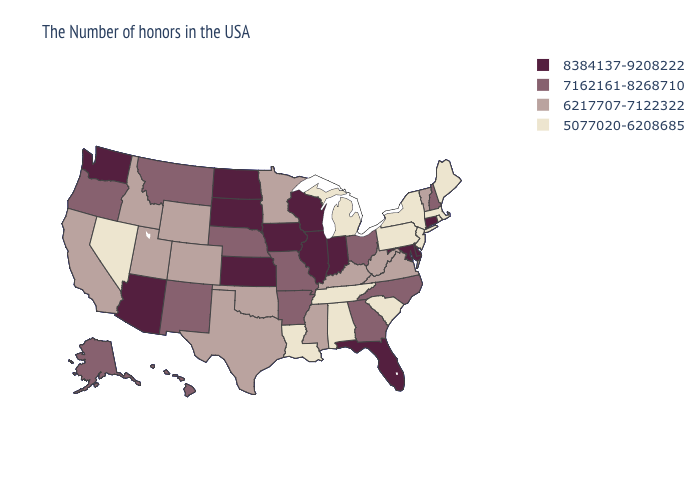What is the highest value in the West ?
Quick response, please. 8384137-9208222. What is the value of New Mexico?
Keep it brief. 7162161-8268710. Name the states that have a value in the range 8384137-9208222?
Concise answer only. Connecticut, Delaware, Maryland, Florida, Indiana, Wisconsin, Illinois, Iowa, Kansas, South Dakota, North Dakota, Arizona, Washington. Among the states that border Indiana , which have the lowest value?
Concise answer only. Michigan. Name the states that have a value in the range 8384137-9208222?
Write a very short answer. Connecticut, Delaware, Maryland, Florida, Indiana, Wisconsin, Illinois, Iowa, Kansas, South Dakota, North Dakota, Arizona, Washington. What is the value of Idaho?
Answer briefly. 6217707-7122322. Name the states that have a value in the range 8384137-9208222?
Keep it brief. Connecticut, Delaware, Maryland, Florida, Indiana, Wisconsin, Illinois, Iowa, Kansas, South Dakota, North Dakota, Arizona, Washington. What is the lowest value in the MidWest?
Give a very brief answer. 5077020-6208685. What is the highest value in states that border California?
Answer briefly. 8384137-9208222. Does Tennessee have a higher value than Montana?
Concise answer only. No. Among the states that border Michigan , does Ohio have the lowest value?
Be succinct. Yes. What is the lowest value in states that border Nevada?
Quick response, please. 6217707-7122322. What is the highest value in states that border Arkansas?
Keep it brief. 7162161-8268710. Is the legend a continuous bar?
Give a very brief answer. No. Which states have the lowest value in the USA?
Write a very short answer. Maine, Massachusetts, Rhode Island, New York, New Jersey, Pennsylvania, South Carolina, Michigan, Alabama, Tennessee, Louisiana, Nevada. 